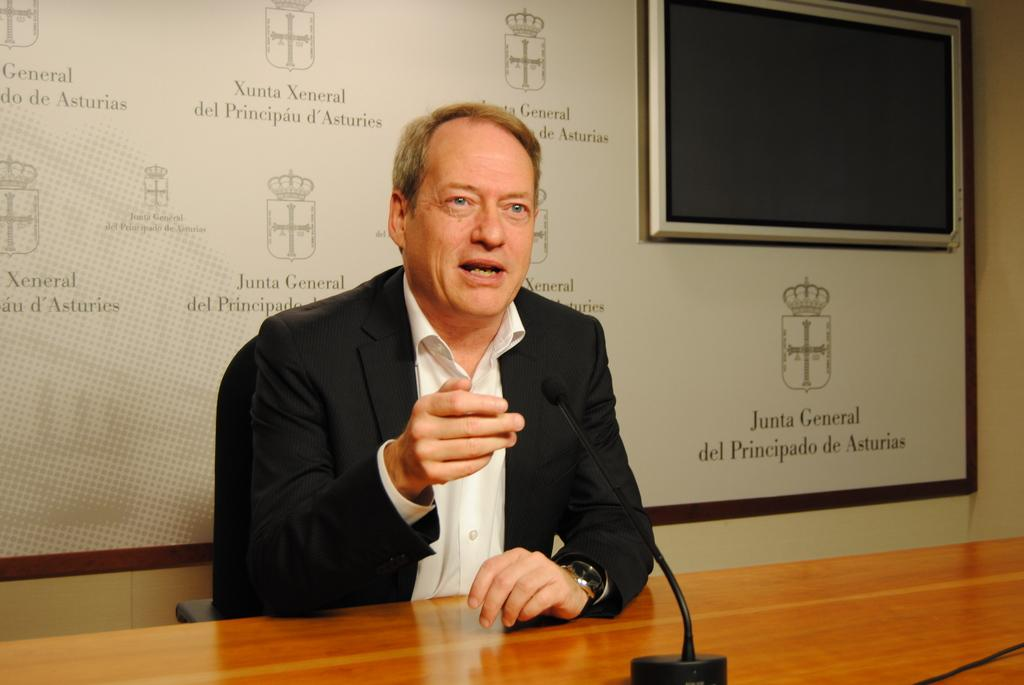What is the main subject of the image? The main subject of the image is a man. What is the man wearing in the image? The man is wearing a black color blazer. What is the man's position in the image? The man is sitting on a chair. What is the chair's position in relation to the table? The chair is in front of a table. What other object can be seen in the image? There is a microphone (Mike) in the image. What is present in the top right corner of the image? There is a screen in the top right corner of the image. What type of meat is the man cooking on the table in the image? There is no meat or cooking activity present in the image; the man is sitting on a chair with a microphone and a screen in the top right corner. 